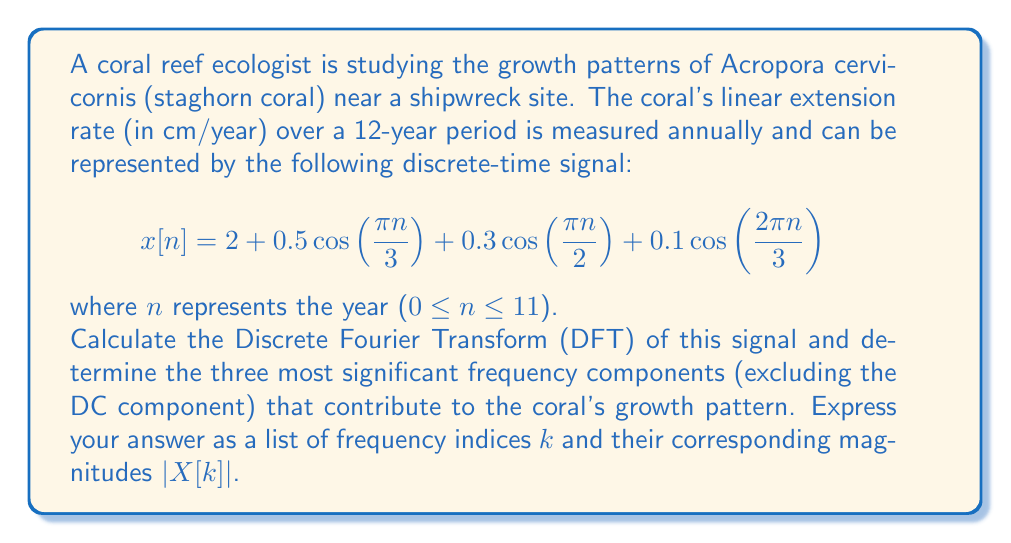Show me your answer to this math problem. To solve this problem, we need to follow these steps:

1) First, let's recall the formula for the Discrete Fourier Transform (DFT):

   $$X[k] = \sum_{n=0}^{N-1} x[n] e^{-j2\pi kn/N}$$

   where N is the total number of samples (in this case, N = 12).

2) Our signal $x[n]$ consists of four components:
   
   - DC component: 2
   - First cosine: $0.5 \cos(\frac{\pi n}{3})$
   - Second cosine: $0.3 \cos(\frac{\pi n}{2})$
   - Third cosine: $0.1 \cos(\frac{2\pi n}{3})$

3) We can use the property of linearity of the DFT and the fact that the DFT of a cosine is a pair of impulses in the frequency domain.

4) For the DC component:
   $X_0[k] = 2$ for $k = 0$, and 0 otherwise.

5) For $0.5 \cos(\frac{\pi n}{3})$:
   This corresponds to a frequency of $\frac{1}{6}$ of the sampling frequency.
   In the DFT, this will appear at $k = 2$ and $k = 10$ (due to periodicity).
   The magnitude will be $0.5 * \frac{N}{2} = 3$ at each of these points.

6) For $0.3 \cos(\frac{\pi n}{2})$:
   This corresponds to a frequency of $\frac{1}{4}$ of the sampling frequency.
   In the DFT, this will appear at $k = 3$ and $k = 9$.
   The magnitude will be $0.3 * \frac{N}{2} = 1.8$ at each of these points.

7) For $0.1 \cos(\frac{2\pi n}{3})$:
   This corresponds to a frequency of $\frac{1}{3}$ of the sampling frequency.
   In the DFT, this will appear at $k = 4$ and $k = 8$.
   The magnitude will be $0.1 * \frac{N}{2} = 0.6$ at each of these points.

8) The magnitudes of the DFT components are:

   $|X[0]| = 24$ (DC component)
   $|X[2]| = |X[10]| = 3$
   $|X[3]| = |X[9]| = 1.8$
   $|X[4]| = |X[8]| = 0.6$

9) Excluding the DC component, the three most significant frequency components are at $k = 2, 10, 3, 9$.
Answer: The three most significant frequency components (excluding the DC component) are:

1. k = 2 and 10, |X[k]| = 3
2. k = 3 and 9, |X[k]| = 1.8
3. k = 4 and 8, |X[k]| = 0.6 